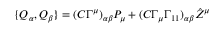Convert formula to latex. <formula><loc_0><loc_0><loc_500><loc_500>\{ Q _ { \alpha } , Q _ { \beta } \} = ( C \Gamma ^ { \mu } ) _ { \alpha \beta } P _ { \mu } + ( C \Gamma _ { \mu } \Gamma _ { 1 1 } ) _ { \alpha \beta } { \hat { Z } } ^ { \mu }</formula> 